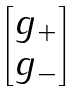<formula> <loc_0><loc_0><loc_500><loc_500>\begin{bmatrix} { g _ { + } } \\ { g _ { - } } \end{bmatrix}</formula> 